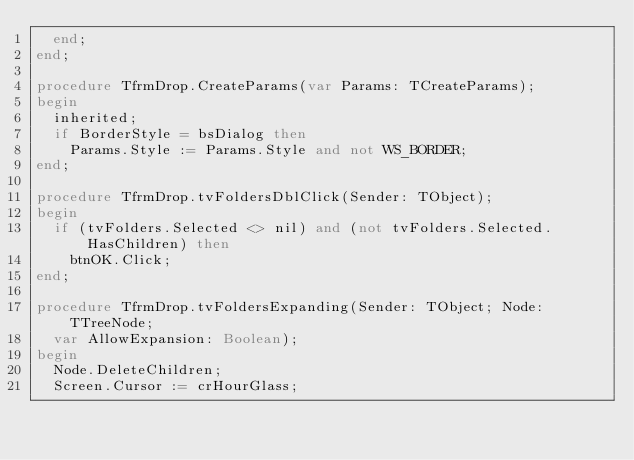Convert code to text. <code><loc_0><loc_0><loc_500><loc_500><_Pascal_>  end;
end;

procedure TfrmDrop.CreateParams(var Params: TCreateParams);
begin
  inherited;
  if BorderStyle = bsDialog then
    Params.Style := Params.Style and not WS_BORDER;
end;

procedure TfrmDrop.tvFoldersDblClick(Sender: TObject);
begin
  if (tvFolders.Selected <> nil) and (not tvFolders.Selected.HasChildren) then
    btnOK.Click;
end;

procedure TfrmDrop.tvFoldersExpanding(Sender: TObject; Node: TTreeNode;
  var AllowExpansion: Boolean);
begin
  Node.DeleteChildren;
  Screen.Cursor := crHourGlass;</code> 